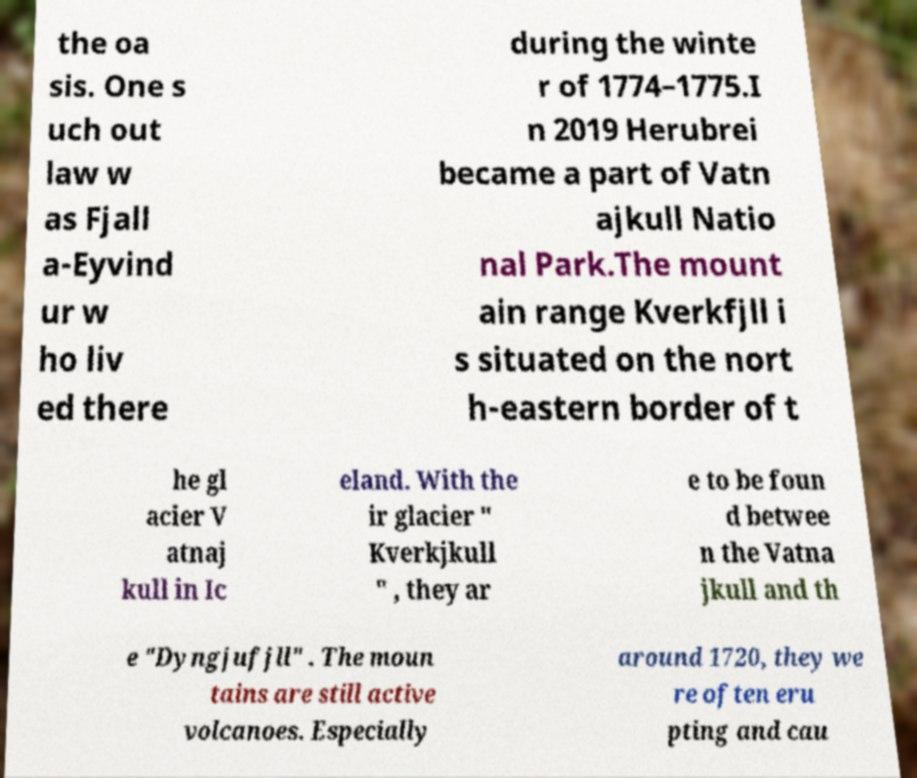For documentation purposes, I need the text within this image transcribed. Could you provide that? the oa sis. One s uch out law w as Fjall a-Eyvind ur w ho liv ed there during the winte r of 1774–1775.I n 2019 Herubrei became a part of Vatn ajkull Natio nal Park.The mount ain range Kverkfjll i s situated on the nort h-eastern border of t he gl acier V atnaj kull in Ic eland. With the ir glacier " Kverkjkull " , they ar e to be foun d betwee n the Vatna jkull and th e "Dyngjufjll" . The moun tains are still active volcanoes. Especially around 1720, they we re often eru pting and cau 